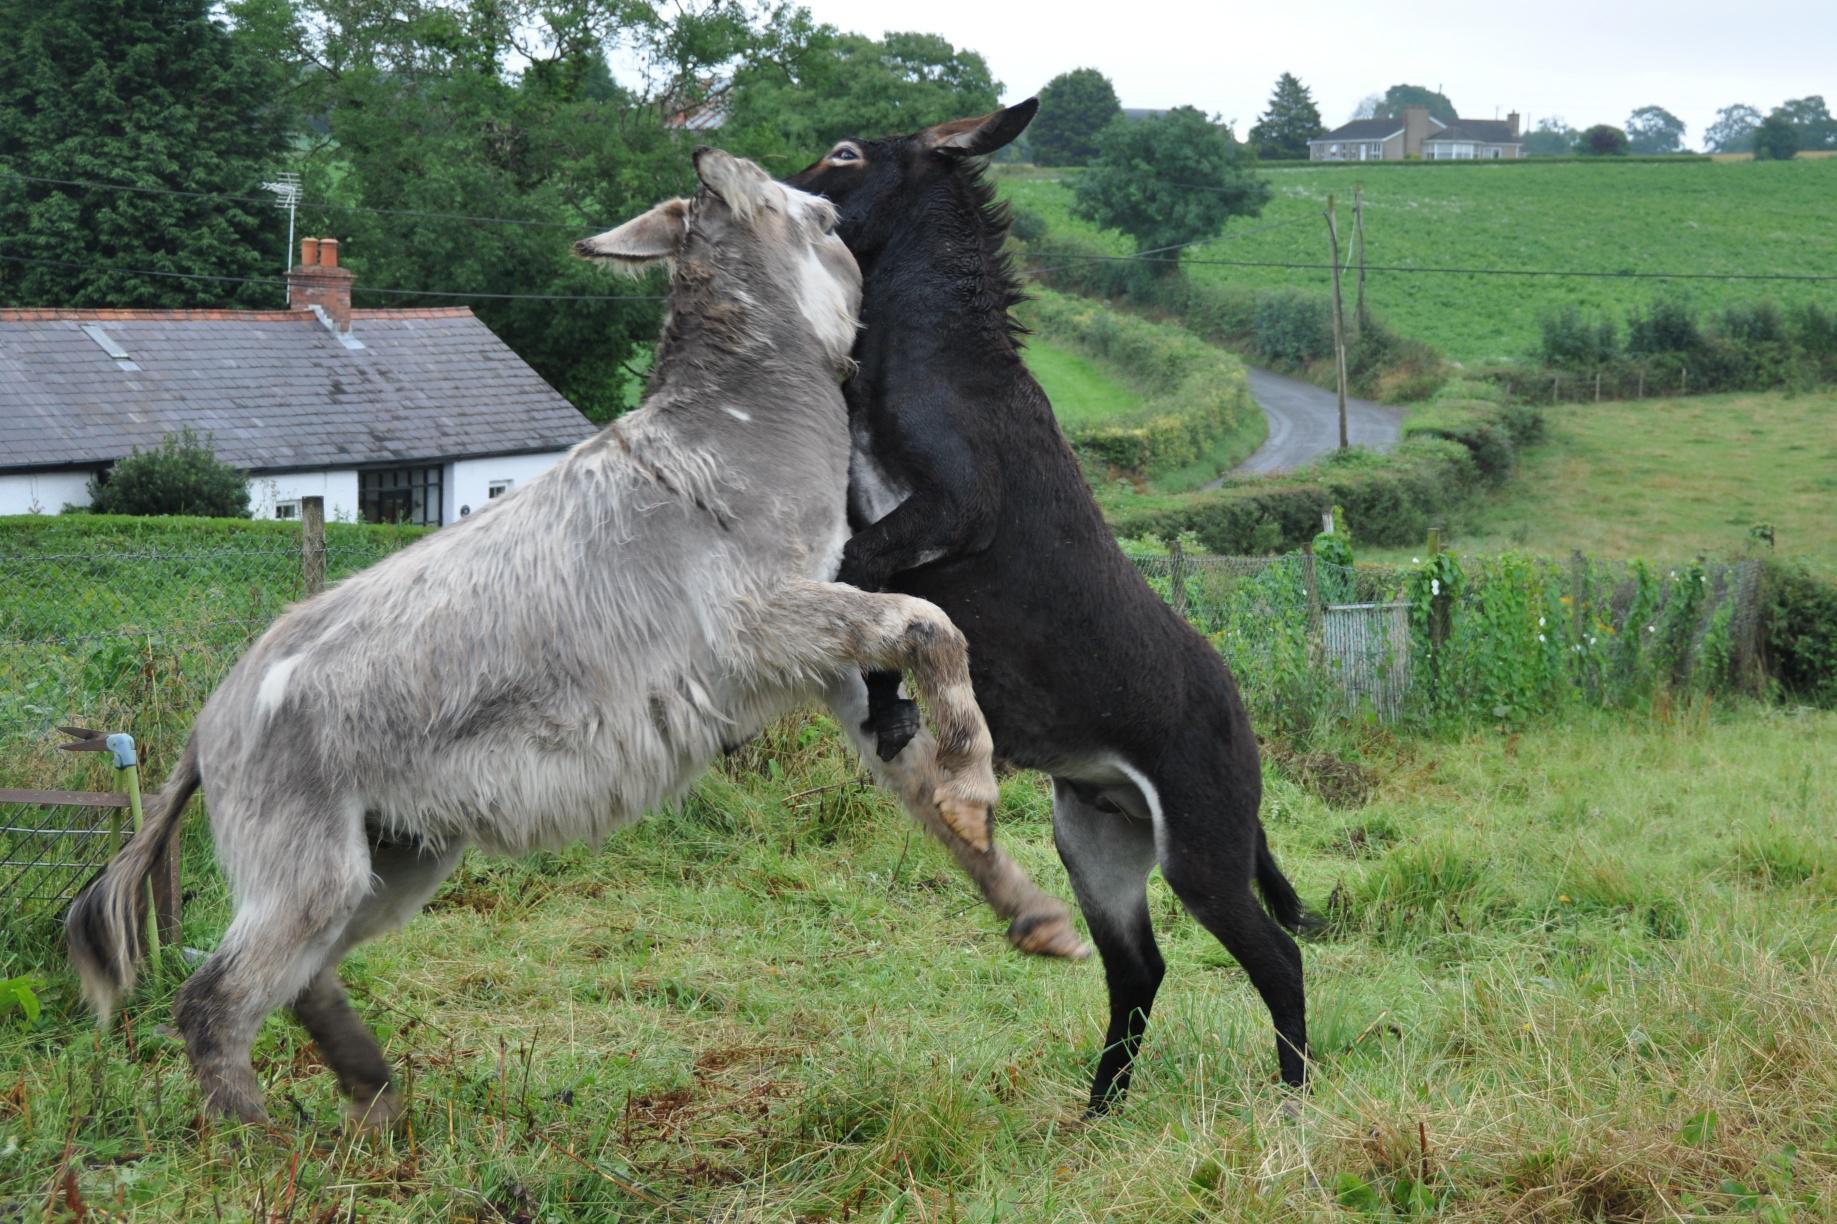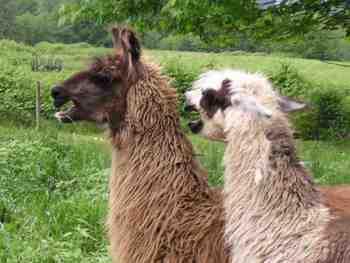The first image is the image on the left, the second image is the image on the right. Examine the images to the left and right. Is the description "In the right image, two dark solid-colored llamas are face-to-face, with their necks stretched." accurate? Answer yes or no. No. The first image is the image on the left, the second image is the image on the right. For the images displayed, is the sentence "One of the images shows two animals fighting while standing on their hind legs." factually correct? Answer yes or no. Yes. 